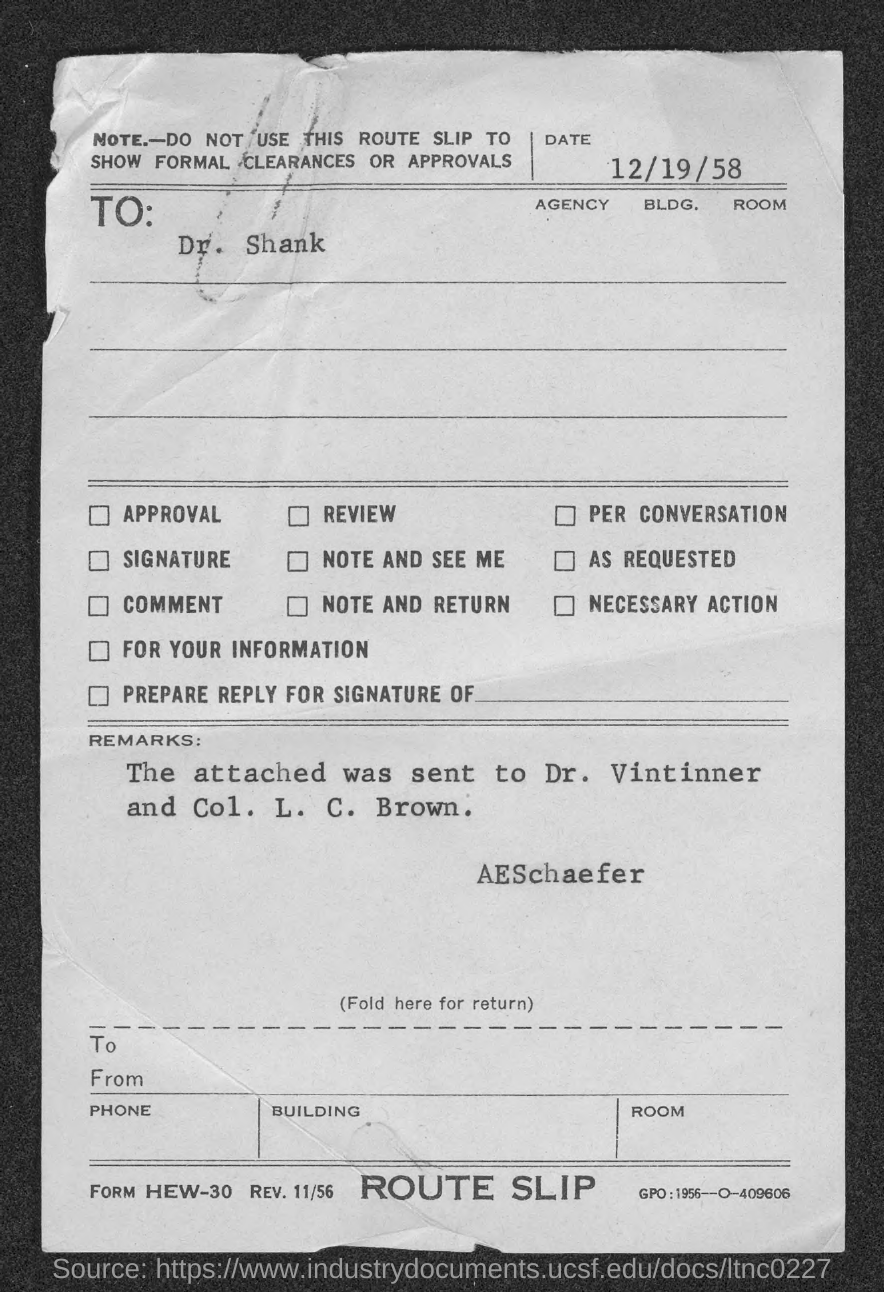Give some essential details in this illustration. The letter is addressed to Dr. Shank. The date is December 19th, 1958. 